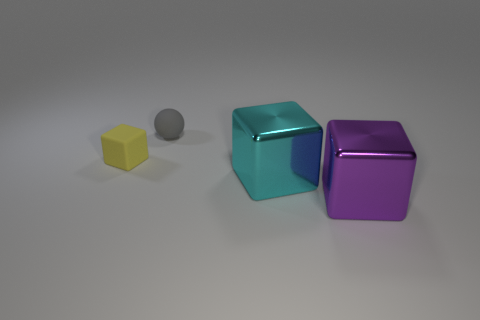There is a yellow thing that is the same shape as the purple thing; what is it made of?
Your answer should be very brief. Rubber. What color is the tiny matte thing in front of the small thing on the right side of the small yellow block?
Your answer should be very brief. Yellow. How many matte things are either small blue cylinders or cyan cubes?
Provide a short and direct response. 0. Does the tiny block have the same material as the gray object?
Offer a terse response. Yes. There is a small thing to the left of the tiny thing that is right of the yellow block; what is its material?
Provide a short and direct response. Rubber. What number of small things are either purple metallic blocks or rubber cylinders?
Give a very brief answer. 0. The gray thing has what size?
Provide a short and direct response. Small. Is the number of small matte things right of the matte cube greater than the number of metallic objects?
Make the answer very short. No. Are there an equal number of cyan things on the left side of the tiny gray matte sphere and purple metallic things behind the tiny block?
Provide a short and direct response. Yes. What color is the object that is in front of the small gray matte ball and on the left side of the cyan metallic cube?
Make the answer very short. Yellow. 